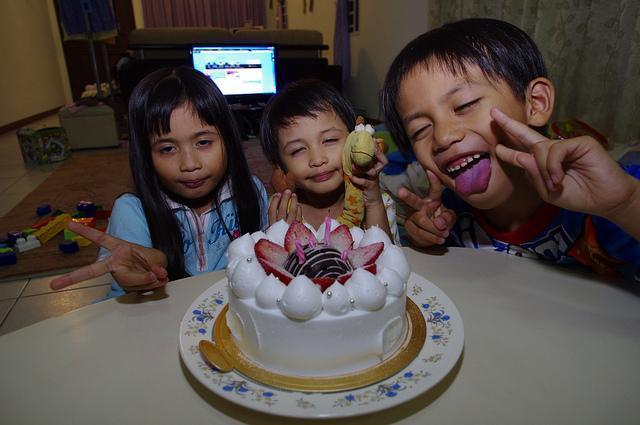How many kids are there?
Give a very brief answer. 3. How many tiers does the cake have?
Give a very brief answer. 1. How many tiers are on the cake?
Give a very brief answer. 1. How many people are wearing glasses?
Give a very brief answer. 0. How many people are visible?
Give a very brief answer. 3. 